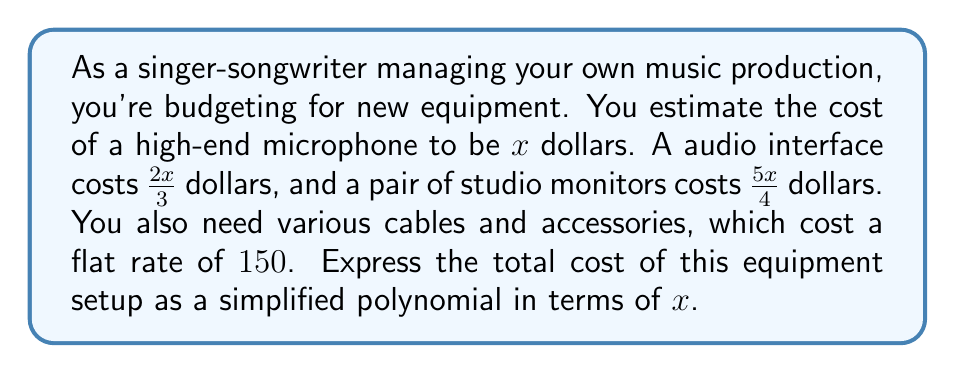Could you help me with this problem? Let's approach this step-by-step:

1) First, let's list out the costs of each item in terms of $x$:
   - Microphone: $x$
   - Audio interface: $\frac{2x}{3}$
   - Studio monitors: $\frac{5x}{4}$
   - Cables and accessories: $150$ (constant)

2) To find the total cost, we need to add all these terms:

   $$x + \frac{2x}{3} + \frac{5x}{4} + 150$$

3) To simplify this expression, we need to find a common denominator for the fractions. The least common multiple of 3 and 4 is 12, so let's convert each term to an equivalent fraction with denominator 12:

   $$\frac{12x}{12} + \frac{8x}{12} + \frac{15x}{12} + 150$$

4) Now we can add the fractions:

   $$\frac{12x + 8x + 15x}{12} + 150$$

5) Simplify the numerator:

   $$\frac{35x}{12} + 150$$

6) This is our simplified polynomial expression. We can't simplify it further because we can't combine the fractional term with the constant term.
Answer: $$\frac{35x}{12} + 150$$ 